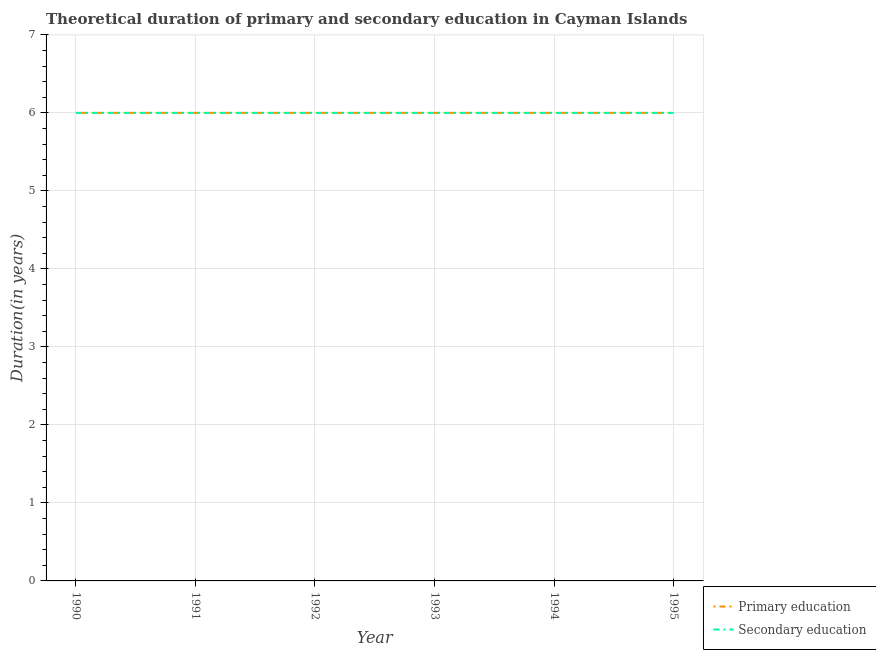Is the number of lines equal to the number of legend labels?
Keep it short and to the point. Yes. Across all years, what is the maximum duration of secondary education?
Offer a very short reply. 6. In which year was the duration of secondary education maximum?
Make the answer very short. 1990. What is the total duration of secondary education in the graph?
Offer a terse response. 36. What is the average duration of primary education per year?
Provide a short and direct response. 6. In the year 1990, what is the difference between the duration of primary education and duration of secondary education?
Make the answer very short. 0. In how many years, is the duration of primary education greater than 6.2 years?
Your response must be concise. 0. Is the duration of secondary education in 1990 less than that in 1991?
Provide a succinct answer. No. What is the difference between the highest and the lowest duration of primary education?
Keep it short and to the point. 0. In how many years, is the duration of primary education greater than the average duration of primary education taken over all years?
Your response must be concise. 0. How many lines are there?
Your response must be concise. 2. How many years are there in the graph?
Offer a terse response. 6. Does the graph contain any zero values?
Your response must be concise. No. Where does the legend appear in the graph?
Give a very brief answer. Bottom right. How are the legend labels stacked?
Provide a succinct answer. Vertical. What is the title of the graph?
Keep it short and to the point. Theoretical duration of primary and secondary education in Cayman Islands. Does "Secondary" appear as one of the legend labels in the graph?
Offer a very short reply. No. What is the label or title of the Y-axis?
Ensure brevity in your answer.  Duration(in years). What is the Duration(in years) of Primary education in 1990?
Provide a short and direct response. 6. What is the Duration(in years) of Primary education in 1991?
Provide a succinct answer. 6. What is the Duration(in years) of Secondary education in 1992?
Your response must be concise. 6. What is the Duration(in years) in Primary education in 1993?
Provide a short and direct response. 6. What is the Duration(in years) in Primary education in 1994?
Offer a very short reply. 6. What is the Duration(in years) of Primary education in 1995?
Give a very brief answer. 6. What is the total Duration(in years) of Secondary education in the graph?
Offer a very short reply. 36. What is the difference between the Duration(in years) in Primary education in 1990 and that in 1991?
Offer a terse response. 0. What is the difference between the Duration(in years) of Secondary education in 1990 and that in 1991?
Ensure brevity in your answer.  0. What is the difference between the Duration(in years) in Secondary education in 1990 and that in 1993?
Keep it short and to the point. 0. What is the difference between the Duration(in years) of Secondary education in 1990 and that in 1994?
Ensure brevity in your answer.  0. What is the difference between the Duration(in years) in Secondary education in 1991 and that in 1992?
Give a very brief answer. 0. What is the difference between the Duration(in years) of Primary education in 1991 and that in 1993?
Provide a short and direct response. 0. What is the difference between the Duration(in years) in Secondary education in 1991 and that in 1993?
Offer a terse response. 0. What is the difference between the Duration(in years) of Primary education in 1991 and that in 1995?
Ensure brevity in your answer.  0. What is the difference between the Duration(in years) of Secondary education in 1991 and that in 1995?
Your answer should be very brief. 0. What is the difference between the Duration(in years) of Primary education in 1992 and that in 1994?
Provide a succinct answer. 0. What is the difference between the Duration(in years) of Secondary education in 1992 and that in 1995?
Your response must be concise. 0. What is the difference between the Duration(in years) in Primary education in 1990 and the Duration(in years) in Secondary education in 1992?
Your answer should be very brief. 0. What is the difference between the Duration(in years) of Primary education in 1990 and the Duration(in years) of Secondary education in 1993?
Your answer should be very brief. 0. What is the difference between the Duration(in years) in Primary education in 1991 and the Duration(in years) in Secondary education in 1992?
Your answer should be compact. 0. What is the difference between the Duration(in years) of Primary education in 1991 and the Duration(in years) of Secondary education in 1994?
Keep it short and to the point. 0. What is the difference between the Duration(in years) in Primary education in 1992 and the Duration(in years) in Secondary education in 1994?
Offer a terse response. 0. What is the difference between the Duration(in years) of Primary education in 1992 and the Duration(in years) of Secondary education in 1995?
Your answer should be very brief. 0. What is the difference between the Duration(in years) in Primary education in 1993 and the Duration(in years) in Secondary education in 1994?
Your answer should be very brief. 0. What is the difference between the Duration(in years) in Primary education in 1994 and the Duration(in years) in Secondary education in 1995?
Make the answer very short. 0. In the year 1991, what is the difference between the Duration(in years) in Primary education and Duration(in years) in Secondary education?
Make the answer very short. 0. In the year 1993, what is the difference between the Duration(in years) in Primary education and Duration(in years) in Secondary education?
Your answer should be compact. 0. In the year 1995, what is the difference between the Duration(in years) in Primary education and Duration(in years) in Secondary education?
Your answer should be very brief. 0. What is the ratio of the Duration(in years) in Primary education in 1990 to that in 1991?
Keep it short and to the point. 1. What is the ratio of the Duration(in years) of Primary education in 1990 to that in 1992?
Your response must be concise. 1. What is the ratio of the Duration(in years) of Secondary education in 1990 to that in 1993?
Provide a short and direct response. 1. What is the ratio of the Duration(in years) in Primary education in 1990 to that in 1994?
Your response must be concise. 1. What is the ratio of the Duration(in years) in Secondary education in 1990 to that in 1994?
Ensure brevity in your answer.  1. What is the ratio of the Duration(in years) in Primary education in 1990 to that in 1995?
Provide a succinct answer. 1. What is the ratio of the Duration(in years) of Primary education in 1991 to that in 1992?
Give a very brief answer. 1. What is the ratio of the Duration(in years) of Secondary education in 1991 to that in 1992?
Offer a very short reply. 1. What is the ratio of the Duration(in years) in Secondary education in 1991 to that in 1993?
Offer a very short reply. 1. What is the ratio of the Duration(in years) in Secondary education in 1991 to that in 1994?
Your answer should be compact. 1. What is the ratio of the Duration(in years) of Primary education in 1991 to that in 1995?
Provide a short and direct response. 1. What is the ratio of the Duration(in years) in Primary education in 1992 to that in 1993?
Keep it short and to the point. 1. What is the ratio of the Duration(in years) in Primary education in 1992 to that in 1994?
Provide a short and direct response. 1. What is the ratio of the Duration(in years) of Primary education in 1993 to that in 1994?
Keep it short and to the point. 1. What is the ratio of the Duration(in years) in Primary education in 1993 to that in 1995?
Make the answer very short. 1. What is the ratio of the Duration(in years) of Secondary education in 1993 to that in 1995?
Offer a terse response. 1. What is the ratio of the Duration(in years) in Secondary education in 1994 to that in 1995?
Your answer should be very brief. 1. What is the difference between the highest and the second highest Duration(in years) of Primary education?
Your answer should be compact. 0. What is the difference between the highest and the second highest Duration(in years) of Secondary education?
Your response must be concise. 0. What is the difference between the highest and the lowest Duration(in years) in Primary education?
Your answer should be compact. 0. 